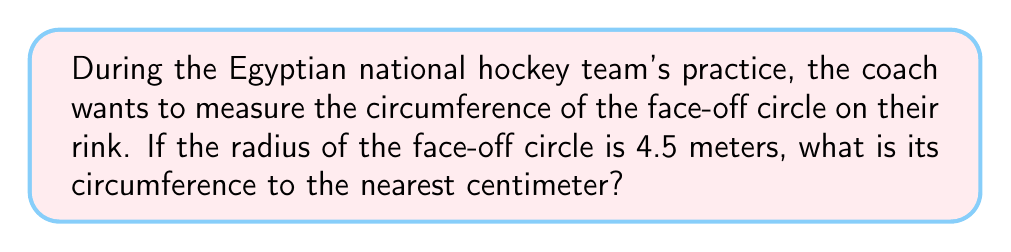Could you help me with this problem? To find the circumference of the face-off circle, we'll follow these steps:

1. Recall the formula for circumference of a circle:
   $C = 2\pi r$, where $C$ is circumference and $r$ is radius

2. We're given that the radius is 4.5 meters. Let's substitute this into our formula:
   $C = 2\pi (4.5)$

3. Simplify:
   $C = 9\pi$

4. Now, let's calculate this value. We'll use $\pi \approx 3.14159$:
   $C \approx 9 \times 3.14159 = 28.27431$ meters

5. The question asks for the answer to the nearest centimeter. There are 100 cm in 1 m, so:
   $28.27431 \text{ m} = 2827.431 \text{ cm}$

6. Rounding to the nearest centimeter:
   $2827.431 \text{ cm} \approx 2827 \text{ cm}$

Therefore, the circumference of the face-off circle is approximately 2827 cm.
Answer: 2827 cm 